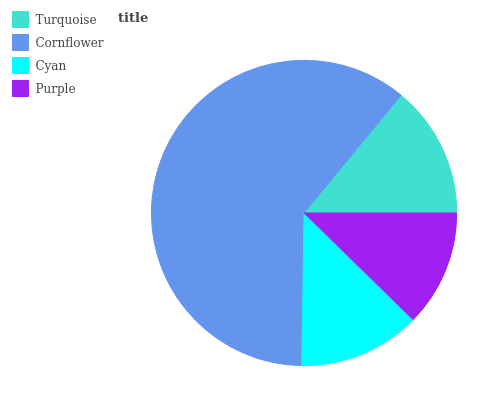Is Purple the minimum?
Answer yes or no. Yes. Is Cornflower the maximum?
Answer yes or no. Yes. Is Cyan the minimum?
Answer yes or no. No. Is Cyan the maximum?
Answer yes or no. No. Is Cornflower greater than Cyan?
Answer yes or no. Yes. Is Cyan less than Cornflower?
Answer yes or no. Yes. Is Cyan greater than Cornflower?
Answer yes or no. No. Is Cornflower less than Cyan?
Answer yes or no. No. Is Turquoise the high median?
Answer yes or no. Yes. Is Cyan the low median?
Answer yes or no. Yes. Is Cornflower the high median?
Answer yes or no. No. Is Cornflower the low median?
Answer yes or no. No. 